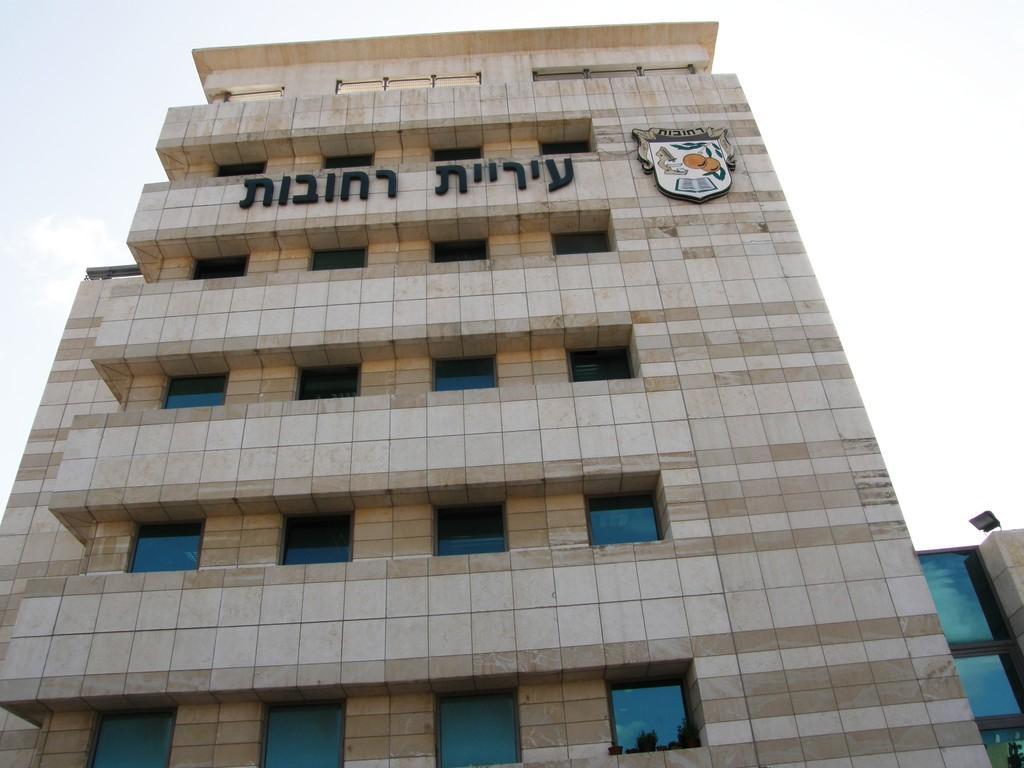Could you give a brief overview of what you see in this image? In this image we can see a building with windows, text and a logo. In the background, we can see a light and the sky. 